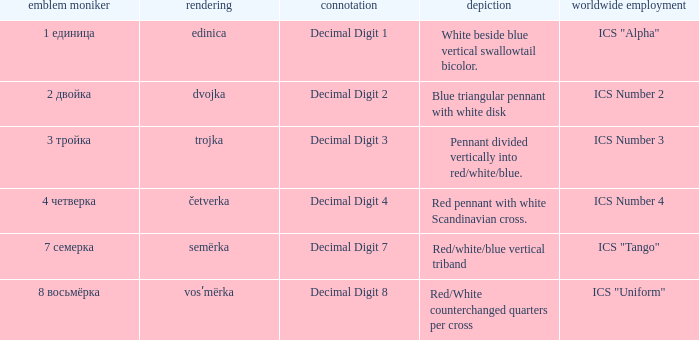How many different descriptions are there for the flag that means decimal digit 2? 1.0. 